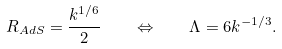<formula> <loc_0><loc_0><loc_500><loc_500>R _ { A d S } = \frac { k ^ { 1 / 6 } } { 2 } \quad \Leftrightarrow \quad \Lambda = 6 k ^ { - 1 / 3 } .</formula> 